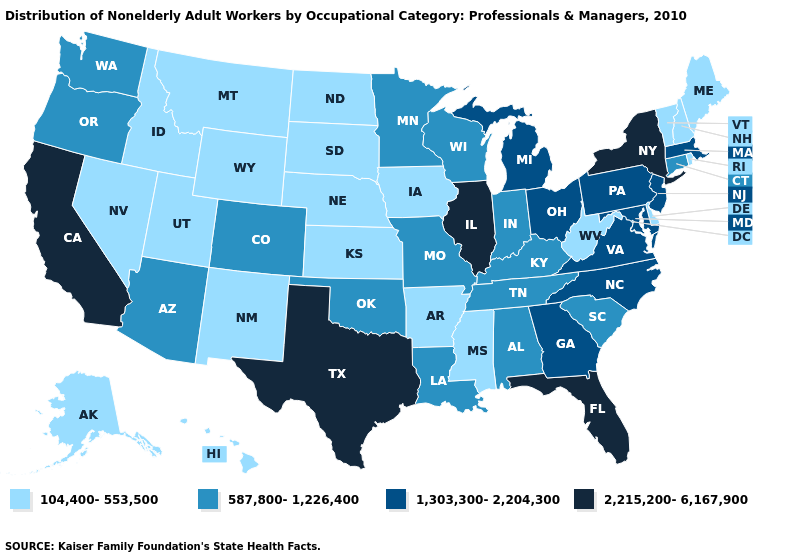What is the value of Delaware?
Answer briefly. 104,400-553,500. Name the states that have a value in the range 104,400-553,500?
Give a very brief answer. Alaska, Arkansas, Delaware, Hawaii, Idaho, Iowa, Kansas, Maine, Mississippi, Montana, Nebraska, Nevada, New Hampshire, New Mexico, North Dakota, Rhode Island, South Dakota, Utah, Vermont, West Virginia, Wyoming. What is the lowest value in the MidWest?
Be succinct. 104,400-553,500. What is the value of Montana?
Answer briefly. 104,400-553,500. What is the highest value in the USA?
Write a very short answer. 2,215,200-6,167,900. Does Pennsylvania have a higher value than Illinois?
Quick response, please. No. Which states have the lowest value in the USA?
Keep it brief. Alaska, Arkansas, Delaware, Hawaii, Idaho, Iowa, Kansas, Maine, Mississippi, Montana, Nebraska, Nevada, New Hampshire, New Mexico, North Dakota, Rhode Island, South Dakota, Utah, Vermont, West Virginia, Wyoming. Does Florida have the highest value in the USA?
Be succinct. Yes. What is the highest value in states that border Indiana?
Quick response, please. 2,215,200-6,167,900. What is the highest value in the Northeast ?
Write a very short answer. 2,215,200-6,167,900. What is the highest value in states that border Arizona?
Answer briefly. 2,215,200-6,167,900. Which states hav the highest value in the MidWest?
Give a very brief answer. Illinois. Name the states that have a value in the range 1,303,300-2,204,300?
Quick response, please. Georgia, Maryland, Massachusetts, Michigan, New Jersey, North Carolina, Ohio, Pennsylvania, Virginia. What is the lowest value in states that border Texas?
Be succinct. 104,400-553,500. 